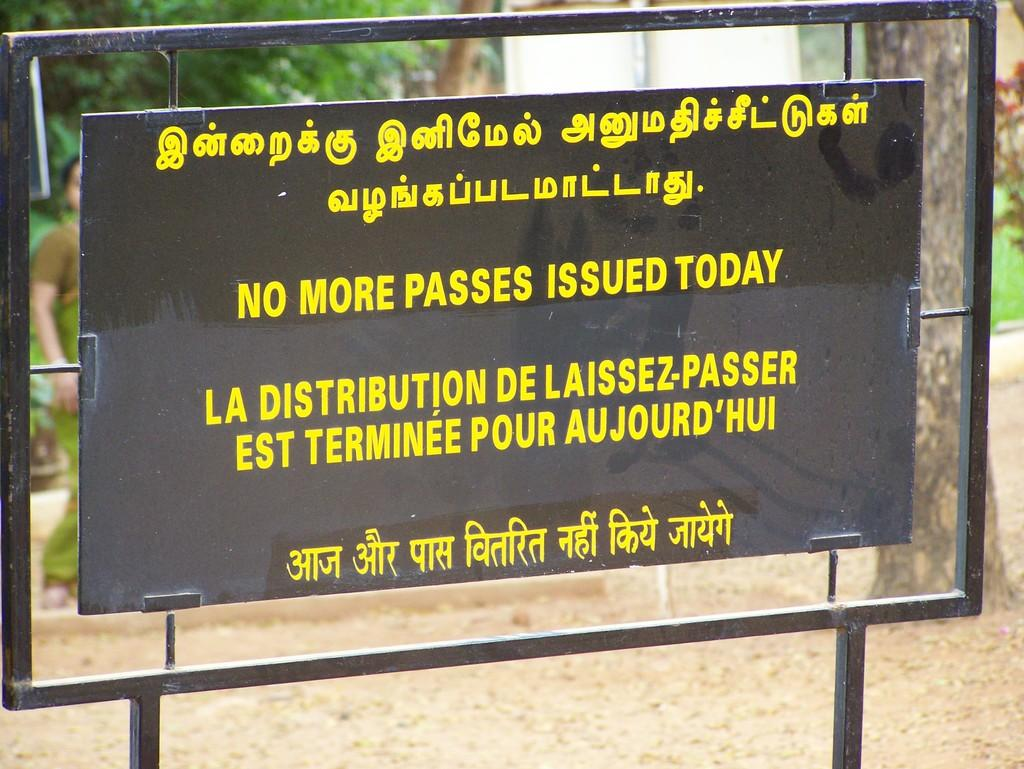<image>
Offer a succinct explanation of the picture presented. A sign informs that no more passes will be issued today. 